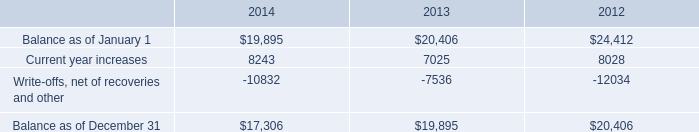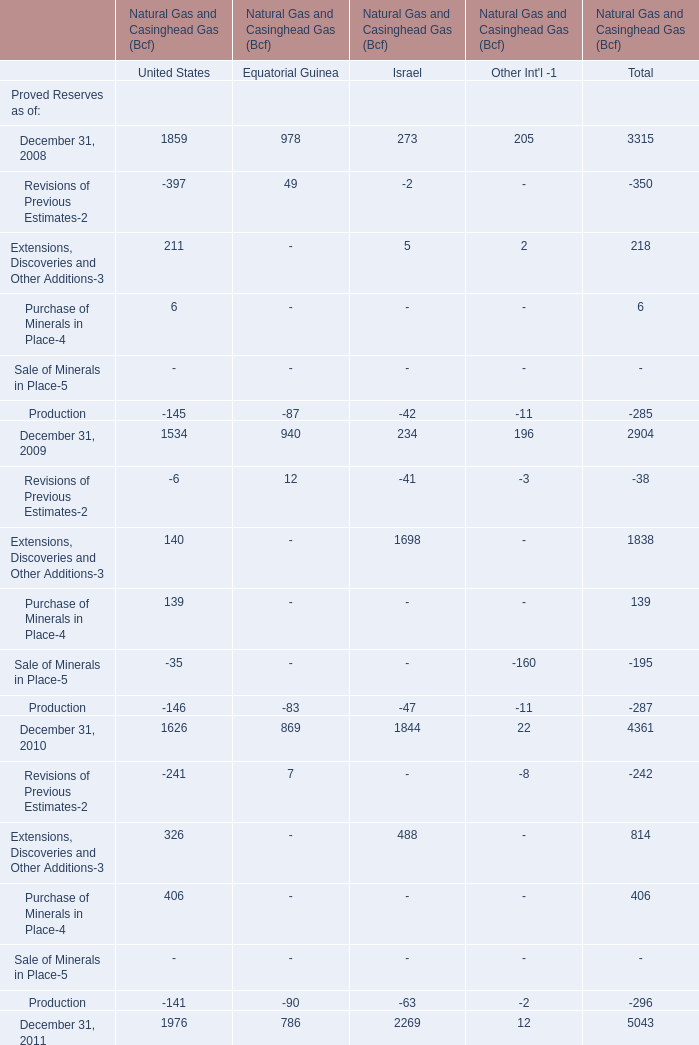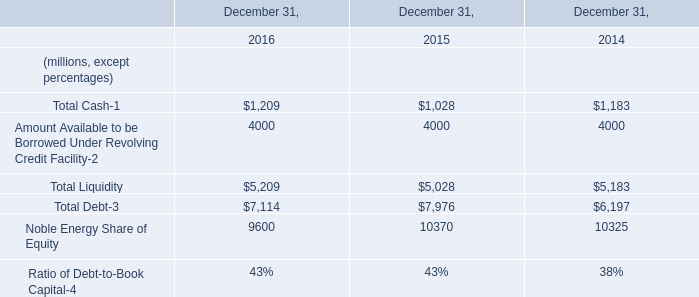What was the total amount of Proved Reserves as of in 2008? 
Answer: 2904. 